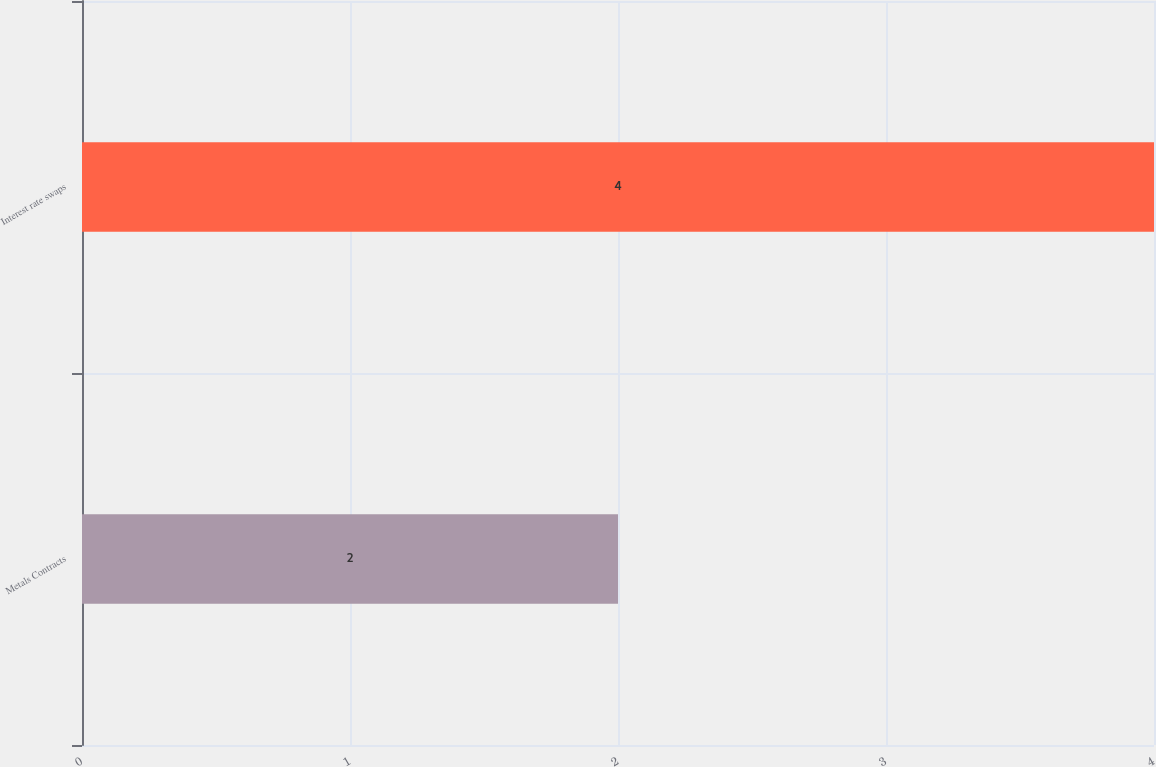Convert chart to OTSL. <chart><loc_0><loc_0><loc_500><loc_500><bar_chart><fcel>Metals Contracts<fcel>Interest rate swaps<nl><fcel>2<fcel>4<nl></chart> 